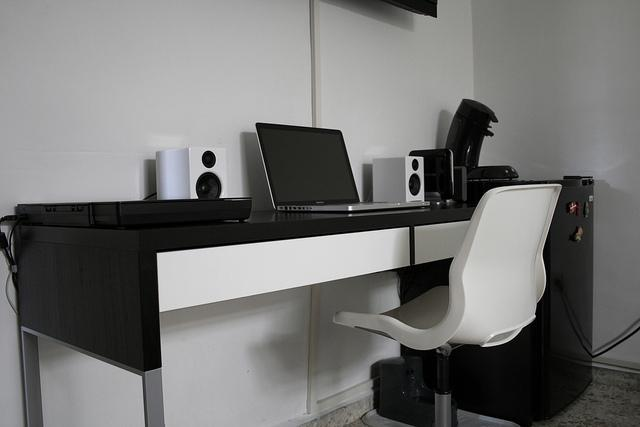Which object in the room can create the most noise?

Choices:
A) laptop
B) chair
C) desk
D) speakers speakers 